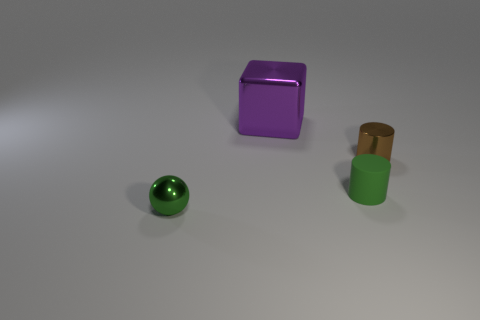What is the color of the tiny metal object left of the purple thing that is right of the small metallic object that is on the left side of the matte cylinder?
Your answer should be very brief. Green. The tiny shiny thing to the right of the tiny green thing that is behind the tiny green metal object is what color?
Give a very brief answer. Brown. Is the number of metal balls on the right side of the brown metallic thing greater than the number of purple blocks in front of the big object?
Ensure brevity in your answer.  No. Are the object that is to the right of the tiny green rubber thing and the green object that is to the right of the big purple metallic thing made of the same material?
Ensure brevity in your answer.  No. Are there any objects in front of the shiny cylinder?
Offer a terse response. Yes. How many purple objects are shiny cubes or shiny cylinders?
Your answer should be very brief. 1. Is the large purple thing made of the same material as the small cylinder that is behind the tiny green rubber cylinder?
Your response must be concise. Yes. What size is the shiny thing that is the same shape as the small green matte object?
Your answer should be very brief. Small. What is the green cylinder made of?
Offer a terse response. Rubber. There is a green thing that is in front of the green object that is behind the small object left of the green cylinder; what is it made of?
Make the answer very short. Metal. 